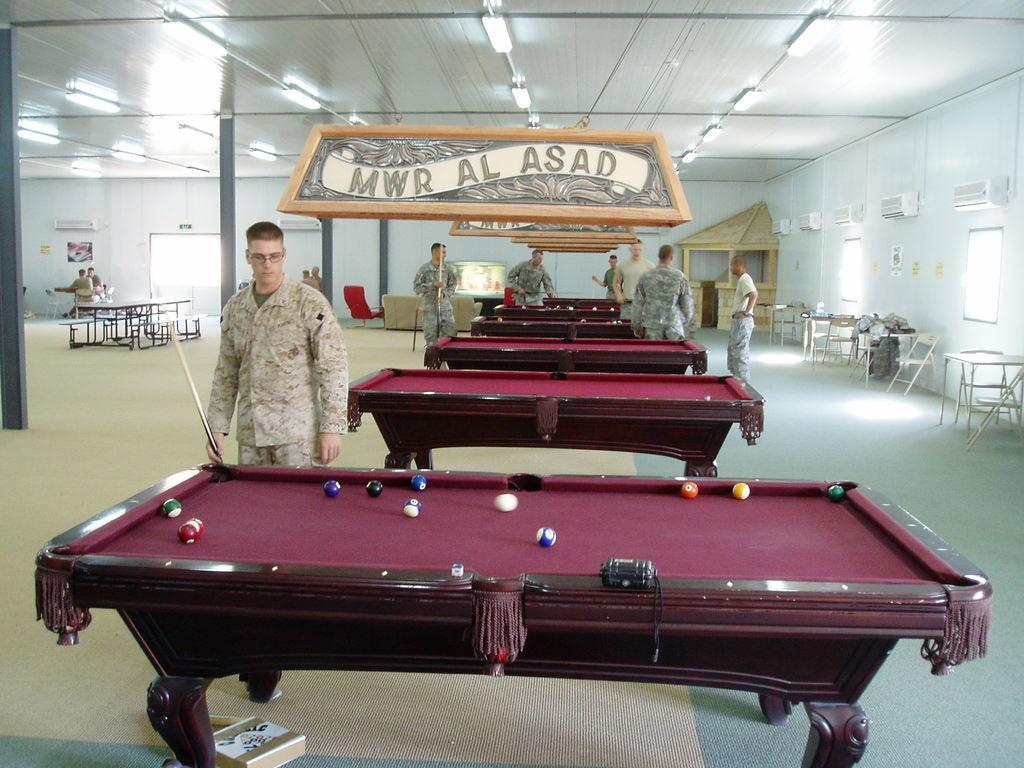What are the men in the image doing? The men in the image are playing pool. What type of game equipment is visible in the image? There are pool tables in the image. What time of day is it in the image? The time of day is not mentioned or depicted in the image, so it cannot be determined. Can you see a rabbit playing pool with the men in the image? There is no rabbit present in the image; only men are playing pool. 